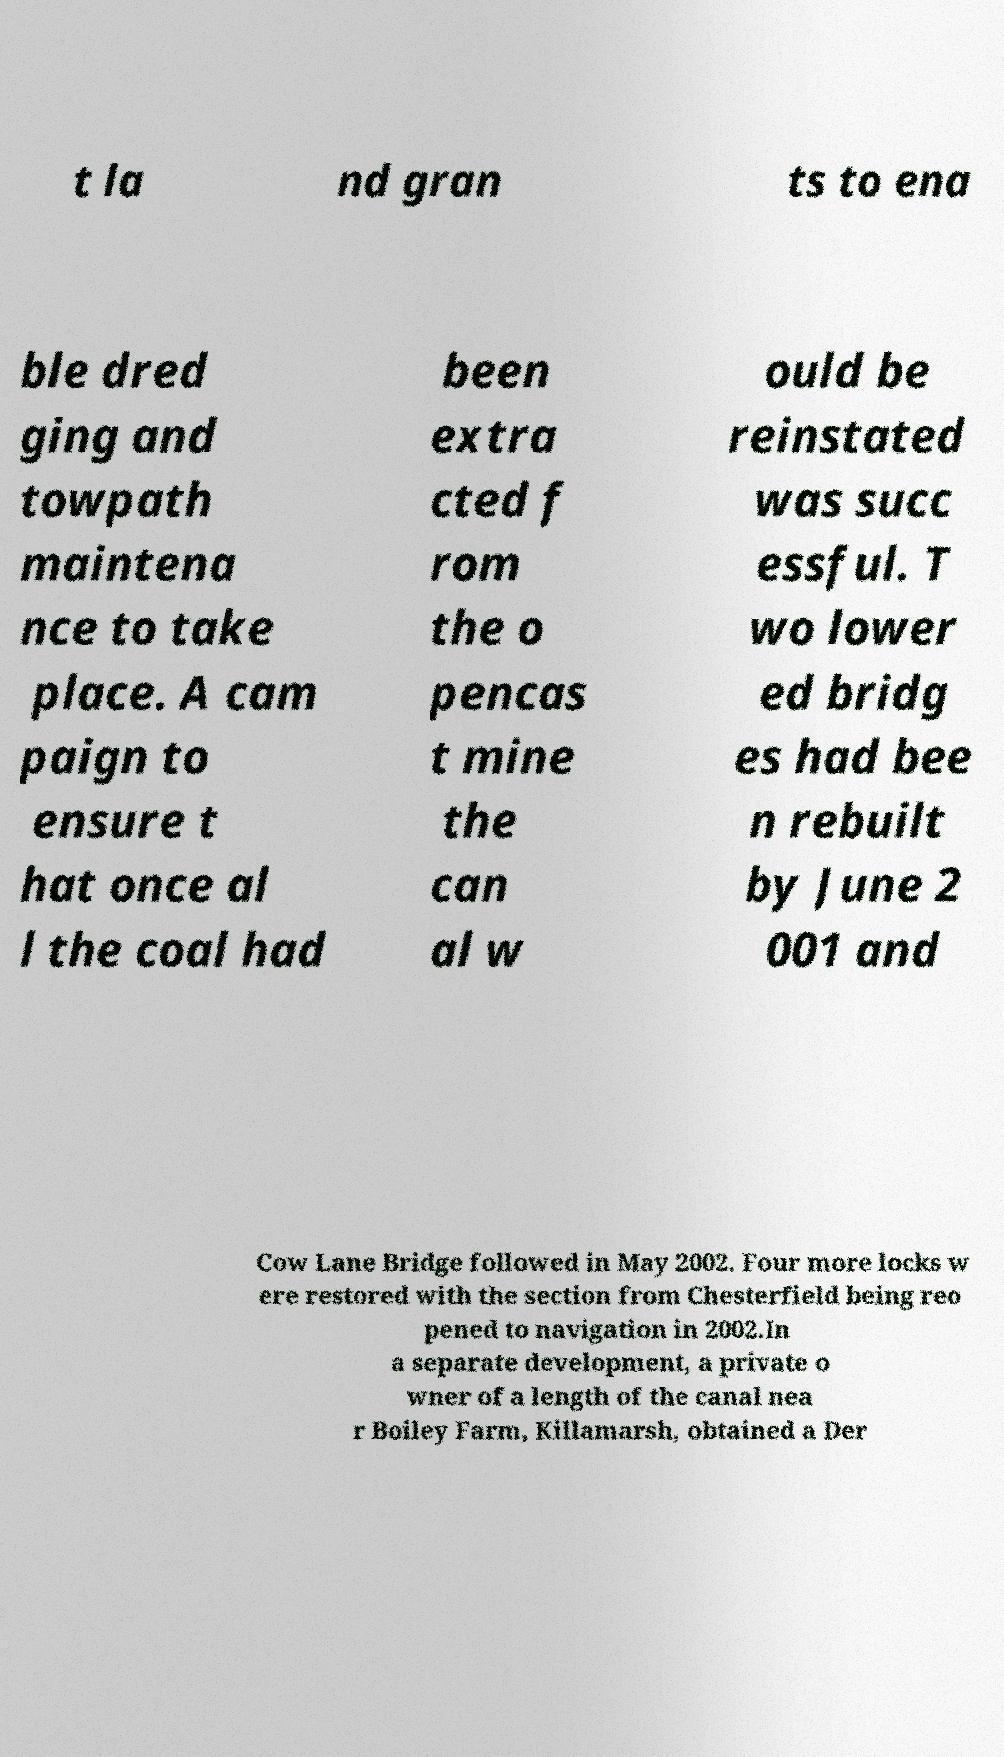For documentation purposes, I need the text within this image transcribed. Could you provide that? t la nd gran ts to ena ble dred ging and towpath maintena nce to take place. A cam paign to ensure t hat once al l the coal had been extra cted f rom the o pencas t mine the can al w ould be reinstated was succ essful. T wo lower ed bridg es had bee n rebuilt by June 2 001 and Cow Lane Bridge followed in May 2002. Four more locks w ere restored with the section from Chesterfield being reo pened to navigation in 2002.In a separate development, a private o wner of a length of the canal nea r Boiley Farm, Killamarsh, obtained a Der 